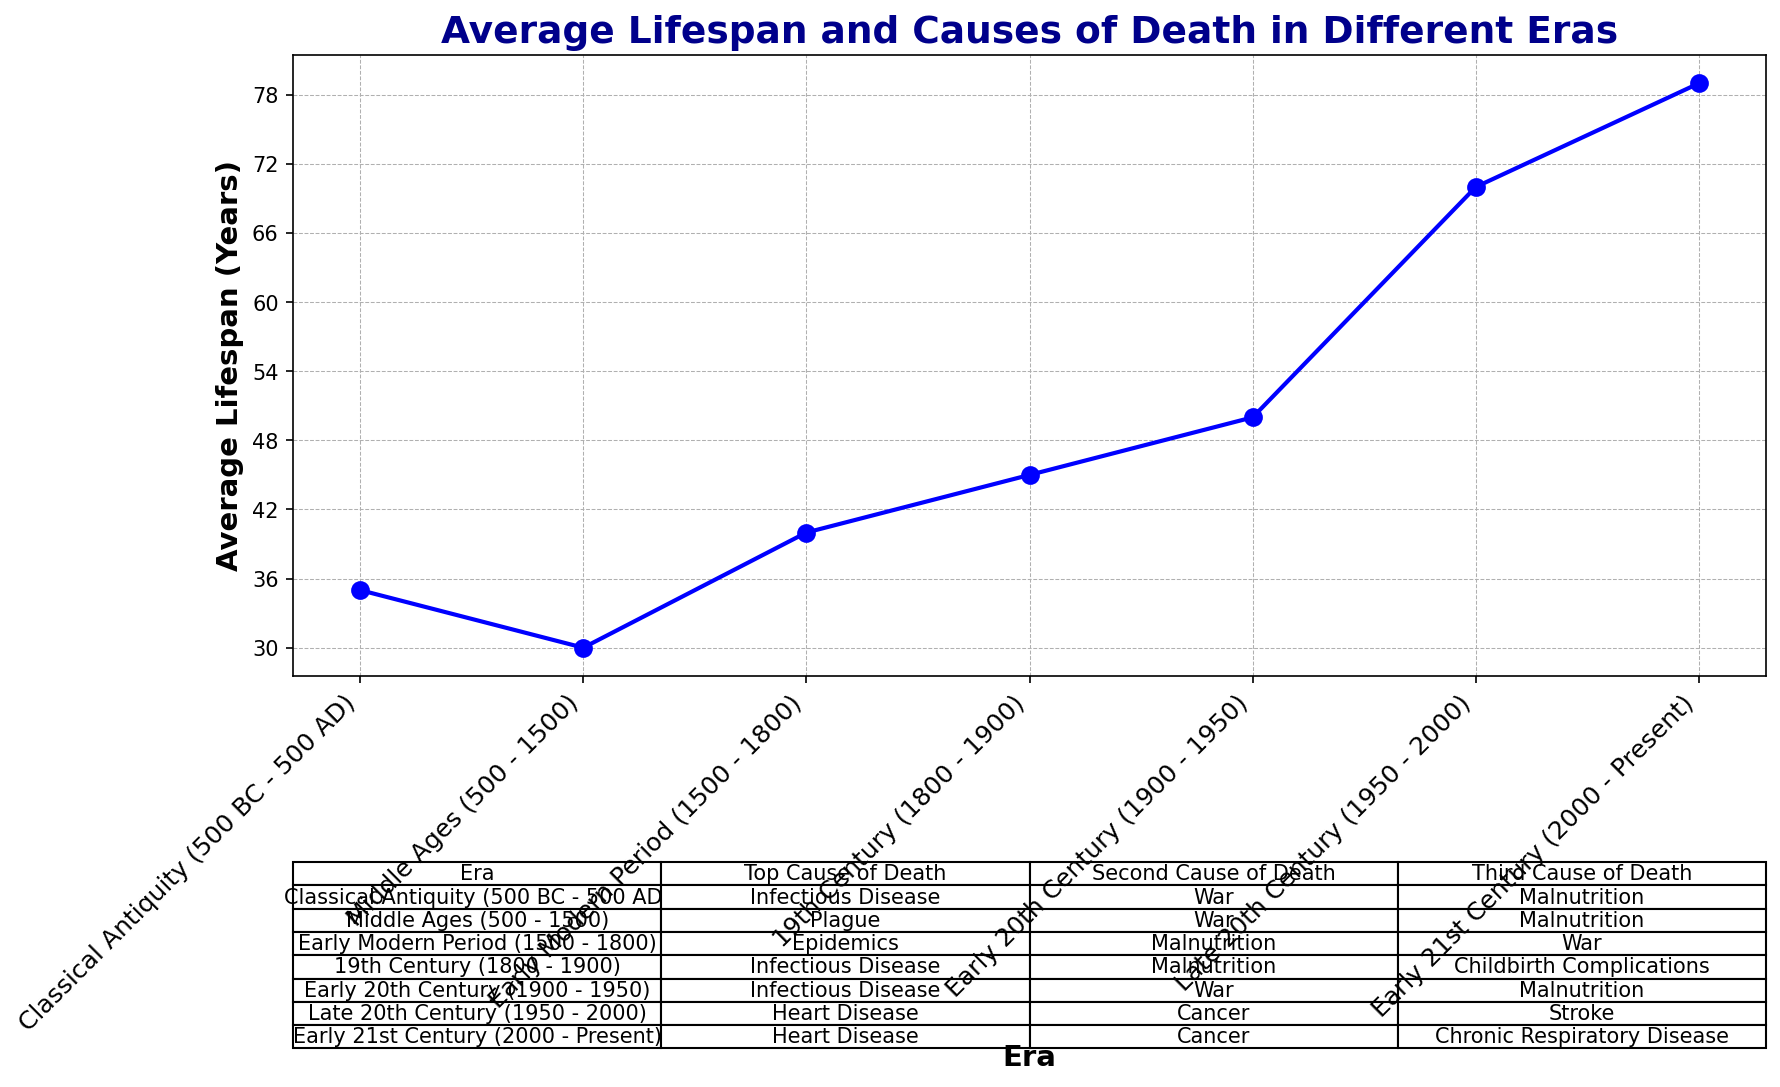What's the era with the highest average lifespan? To find the era with the highest average lifespan, look at the plot and identify the era with the highest point on the y-axis. The Early 21st Century has the highest plotted point.
Answer: Early 21st Century Compare the average lifespan in the Middle Ages to the Early Modern Period. Which is greater and by how much? Look for the plotted points for both eras on the y-axis. The Middle Ages have an average lifespan of 30 years, and the Early Modern Period has 40 years. Subtract 30 from 40.
Answer: Early Modern Period, by 10 years Which era has malnutrition as a top cause of death? Check the table for the column "Top Cause of Death." None of the eras listed have malnutrition as the top cause of death.
Answer: None How did the average lifespan change from the 19th century to the early 20th century? Note the plotted points for both eras. The 19th century has 45 years, and the early 20th century has 50 years. Subtract 45 from 50.
Answer: Increased by 5 years Identify an era where war was a major cause of death. Look at the table for instances of "War" in the columns "Top Cause of Death," "Second Cause of Death," and "Third Cause of Death." The Middle Ages, Classical Antiquity, Early Modern Period, and Early 20th Century list war as a major cause of death.
Answer: Multiple eras (Middle Ages, Classical Antiquity, Early Modern Period, Early 20th Century) What is the difference in the average lifespan between the Classical Antiquity and the Late 20th Century? Look at the y-axis for both eras. Classical Antiquity has 35 years, while the Late 20th Century has 70 years. Subtract 35 from 70.
Answer: 35 years Which era had childbirth complications as a major cause of death? Check the table's "Third Cause of Death" column. The 19th Century lists "Childbirth Complications" as one of the causes.
Answer: 19th Century Determine the increase in average lifespan from the Early Modern Period to the Early 21st Century. Identify the lifespans of both eras from the plot. The Early Modern Period is at 40 years, and the Early 21st Century is at 79 years. Subtract 40 from 79.
Answer: Increased by 39 years In which era did chronic respiratory disease become a major cause of death? Examine the table for instances of "Chronic Respiratory Disease." It appears in the Early 21st Century as the third cause of death.
Answer: Early 21st Century 